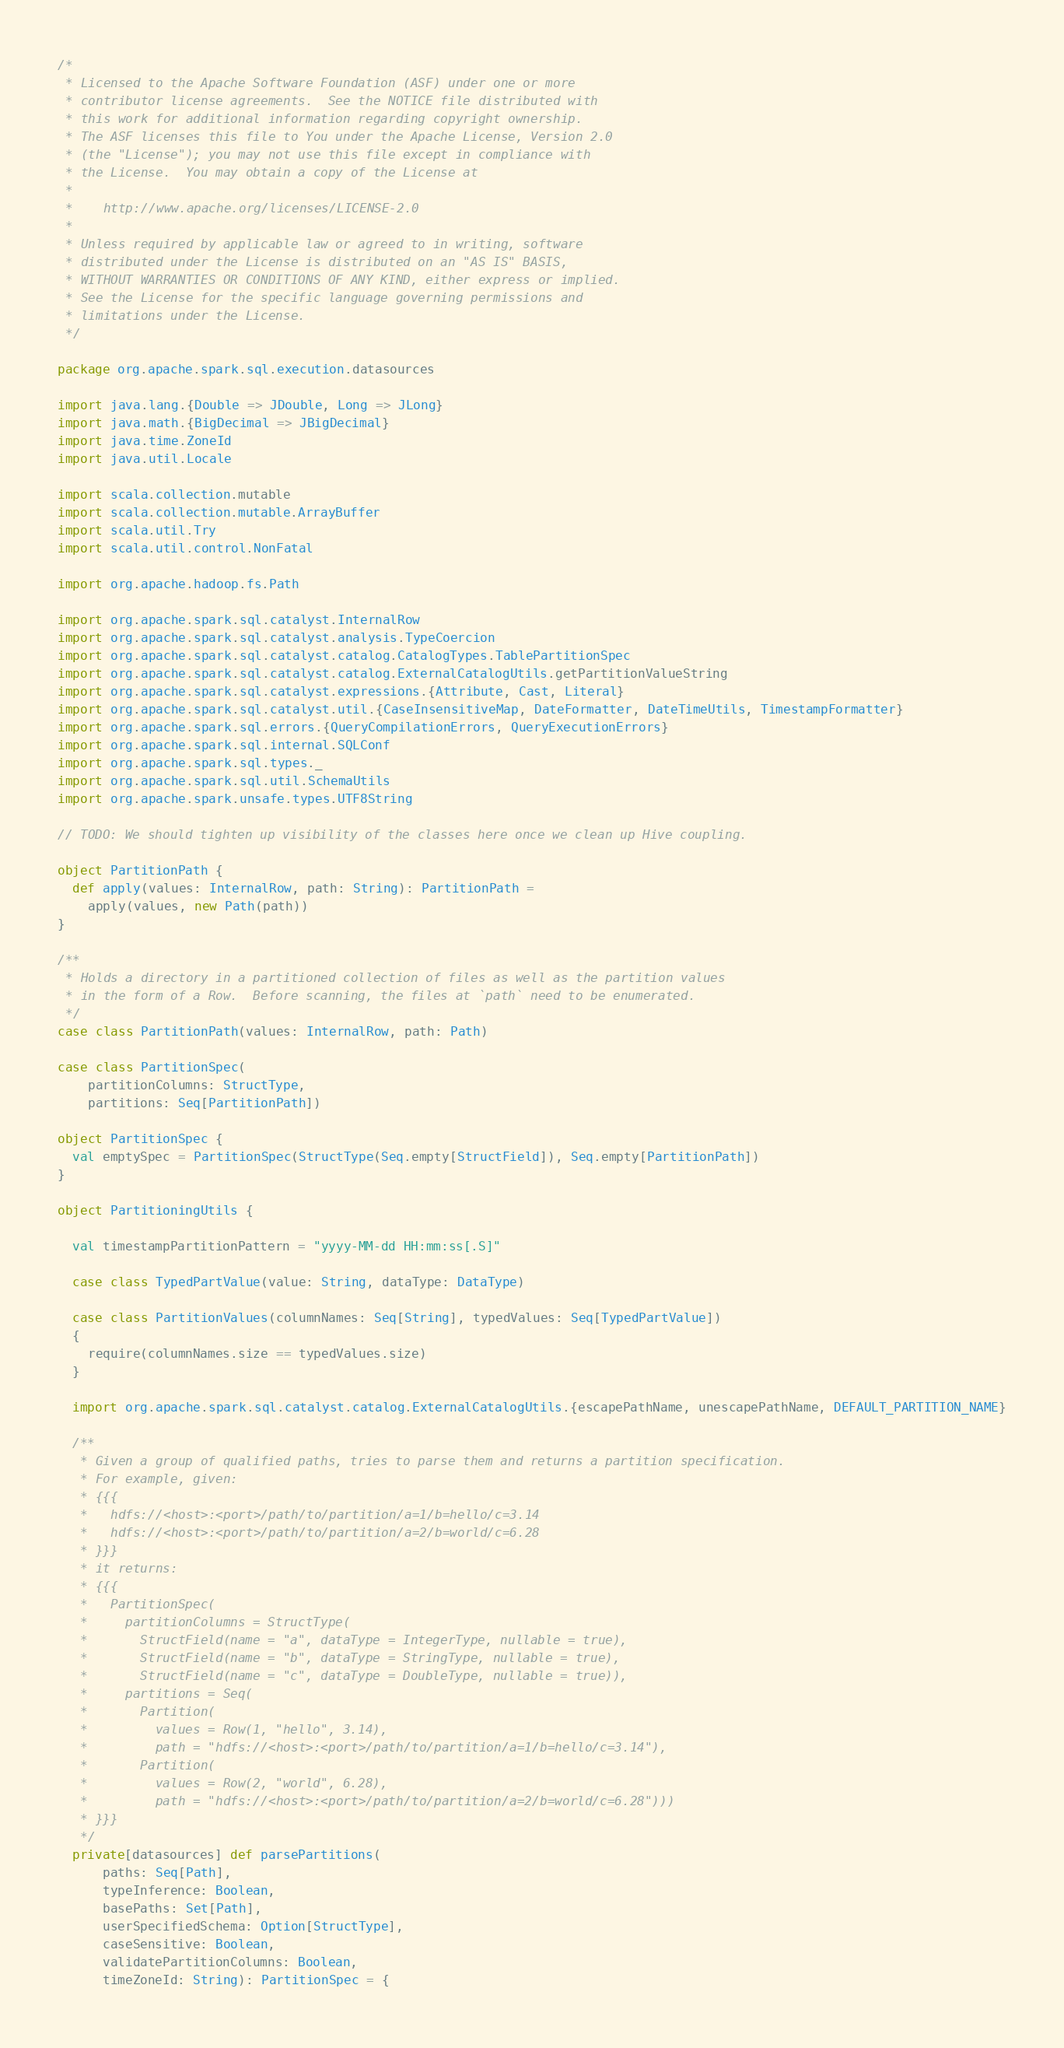Convert code to text. <code><loc_0><loc_0><loc_500><loc_500><_Scala_>/*
 * Licensed to the Apache Software Foundation (ASF) under one or more
 * contributor license agreements.  See the NOTICE file distributed with
 * this work for additional information regarding copyright ownership.
 * The ASF licenses this file to You under the Apache License, Version 2.0
 * (the "License"); you may not use this file except in compliance with
 * the License.  You may obtain a copy of the License at
 *
 *    http://www.apache.org/licenses/LICENSE-2.0
 *
 * Unless required by applicable law or agreed to in writing, software
 * distributed under the License is distributed on an "AS IS" BASIS,
 * WITHOUT WARRANTIES OR CONDITIONS OF ANY KIND, either express or implied.
 * See the License for the specific language governing permissions and
 * limitations under the License.
 */

package org.apache.spark.sql.execution.datasources

import java.lang.{Double => JDouble, Long => JLong}
import java.math.{BigDecimal => JBigDecimal}
import java.time.ZoneId
import java.util.Locale

import scala.collection.mutable
import scala.collection.mutable.ArrayBuffer
import scala.util.Try
import scala.util.control.NonFatal

import org.apache.hadoop.fs.Path

import org.apache.spark.sql.catalyst.InternalRow
import org.apache.spark.sql.catalyst.analysis.TypeCoercion
import org.apache.spark.sql.catalyst.catalog.CatalogTypes.TablePartitionSpec
import org.apache.spark.sql.catalyst.catalog.ExternalCatalogUtils.getPartitionValueString
import org.apache.spark.sql.catalyst.expressions.{Attribute, Cast, Literal}
import org.apache.spark.sql.catalyst.util.{CaseInsensitiveMap, DateFormatter, DateTimeUtils, TimestampFormatter}
import org.apache.spark.sql.errors.{QueryCompilationErrors, QueryExecutionErrors}
import org.apache.spark.sql.internal.SQLConf
import org.apache.spark.sql.types._
import org.apache.spark.sql.util.SchemaUtils
import org.apache.spark.unsafe.types.UTF8String

// TODO: We should tighten up visibility of the classes here once we clean up Hive coupling.

object PartitionPath {
  def apply(values: InternalRow, path: String): PartitionPath =
    apply(values, new Path(path))
}

/**
 * Holds a directory in a partitioned collection of files as well as the partition values
 * in the form of a Row.  Before scanning, the files at `path` need to be enumerated.
 */
case class PartitionPath(values: InternalRow, path: Path)

case class PartitionSpec(
    partitionColumns: StructType,
    partitions: Seq[PartitionPath])

object PartitionSpec {
  val emptySpec = PartitionSpec(StructType(Seq.empty[StructField]), Seq.empty[PartitionPath])
}

object PartitioningUtils {

  val timestampPartitionPattern = "yyyy-MM-dd HH:mm:ss[.S]"

  case class TypedPartValue(value: String, dataType: DataType)

  case class PartitionValues(columnNames: Seq[String], typedValues: Seq[TypedPartValue])
  {
    require(columnNames.size == typedValues.size)
  }

  import org.apache.spark.sql.catalyst.catalog.ExternalCatalogUtils.{escapePathName, unescapePathName, DEFAULT_PARTITION_NAME}

  /**
   * Given a group of qualified paths, tries to parse them and returns a partition specification.
   * For example, given:
   * {{{
   *   hdfs://<host>:<port>/path/to/partition/a=1/b=hello/c=3.14
   *   hdfs://<host>:<port>/path/to/partition/a=2/b=world/c=6.28
   * }}}
   * it returns:
   * {{{
   *   PartitionSpec(
   *     partitionColumns = StructType(
   *       StructField(name = "a", dataType = IntegerType, nullable = true),
   *       StructField(name = "b", dataType = StringType, nullable = true),
   *       StructField(name = "c", dataType = DoubleType, nullable = true)),
   *     partitions = Seq(
   *       Partition(
   *         values = Row(1, "hello", 3.14),
   *         path = "hdfs://<host>:<port>/path/to/partition/a=1/b=hello/c=3.14"),
   *       Partition(
   *         values = Row(2, "world", 6.28),
   *         path = "hdfs://<host>:<port>/path/to/partition/a=2/b=world/c=6.28")))
   * }}}
   */
  private[datasources] def parsePartitions(
      paths: Seq[Path],
      typeInference: Boolean,
      basePaths: Set[Path],
      userSpecifiedSchema: Option[StructType],
      caseSensitive: Boolean,
      validatePartitionColumns: Boolean,
      timeZoneId: String): PartitionSpec = {</code> 